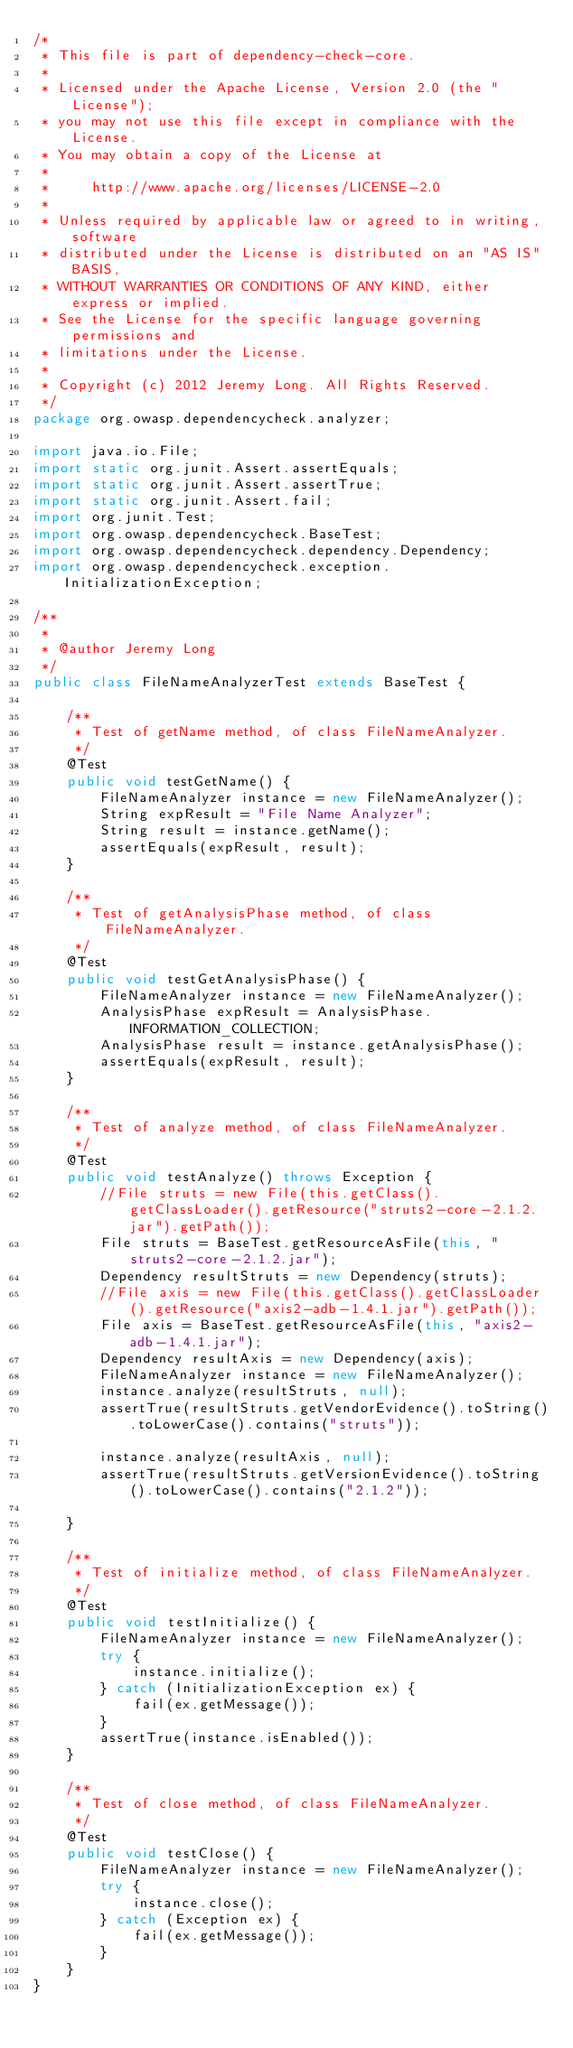<code> <loc_0><loc_0><loc_500><loc_500><_Java_>/*
 * This file is part of dependency-check-core.
 *
 * Licensed under the Apache License, Version 2.0 (the "License");
 * you may not use this file except in compliance with the License.
 * You may obtain a copy of the License at
 *
 *     http://www.apache.org/licenses/LICENSE-2.0
 *
 * Unless required by applicable law or agreed to in writing, software
 * distributed under the License is distributed on an "AS IS" BASIS,
 * WITHOUT WARRANTIES OR CONDITIONS OF ANY KIND, either express or implied.
 * See the License for the specific language governing permissions and
 * limitations under the License.
 *
 * Copyright (c) 2012 Jeremy Long. All Rights Reserved.
 */
package org.owasp.dependencycheck.analyzer;

import java.io.File;
import static org.junit.Assert.assertEquals;
import static org.junit.Assert.assertTrue;
import static org.junit.Assert.fail;
import org.junit.Test;
import org.owasp.dependencycheck.BaseTest;
import org.owasp.dependencycheck.dependency.Dependency;
import org.owasp.dependencycheck.exception.InitializationException;

/**
 *
 * @author Jeremy Long
 */
public class FileNameAnalyzerTest extends BaseTest {

    /**
     * Test of getName method, of class FileNameAnalyzer.
     */
    @Test
    public void testGetName() {
        FileNameAnalyzer instance = new FileNameAnalyzer();
        String expResult = "File Name Analyzer";
        String result = instance.getName();
        assertEquals(expResult, result);
    }

    /**
     * Test of getAnalysisPhase method, of class FileNameAnalyzer.
     */
    @Test
    public void testGetAnalysisPhase() {
        FileNameAnalyzer instance = new FileNameAnalyzer();
        AnalysisPhase expResult = AnalysisPhase.INFORMATION_COLLECTION;
        AnalysisPhase result = instance.getAnalysisPhase();
        assertEquals(expResult, result);
    }

    /**
     * Test of analyze method, of class FileNameAnalyzer.
     */
    @Test
    public void testAnalyze() throws Exception {
        //File struts = new File(this.getClass().getClassLoader().getResource("struts2-core-2.1.2.jar").getPath());
        File struts = BaseTest.getResourceAsFile(this, "struts2-core-2.1.2.jar");
        Dependency resultStruts = new Dependency(struts);
        //File axis = new File(this.getClass().getClassLoader().getResource("axis2-adb-1.4.1.jar").getPath());
        File axis = BaseTest.getResourceAsFile(this, "axis2-adb-1.4.1.jar");
        Dependency resultAxis = new Dependency(axis);
        FileNameAnalyzer instance = new FileNameAnalyzer();
        instance.analyze(resultStruts, null);
        assertTrue(resultStruts.getVendorEvidence().toString().toLowerCase().contains("struts"));

        instance.analyze(resultAxis, null);
        assertTrue(resultStruts.getVersionEvidence().toString().toLowerCase().contains("2.1.2"));

    }

    /**
     * Test of initialize method, of class FileNameAnalyzer.
     */
    @Test
    public void testInitialize() {
        FileNameAnalyzer instance = new FileNameAnalyzer();
        try {
            instance.initialize();
        } catch (InitializationException ex) {
            fail(ex.getMessage());
        }
        assertTrue(instance.isEnabled());
    }

    /**
     * Test of close method, of class FileNameAnalyzer.
     */
    @Test
    public void testClose() {
        FileNameAnalyzer instance = new FileNameAnalyzer();
        try {
            instance.close();
        } catch (Exception ex) {
            fail(ex.getMessage());
        }
    }
}
</code> 